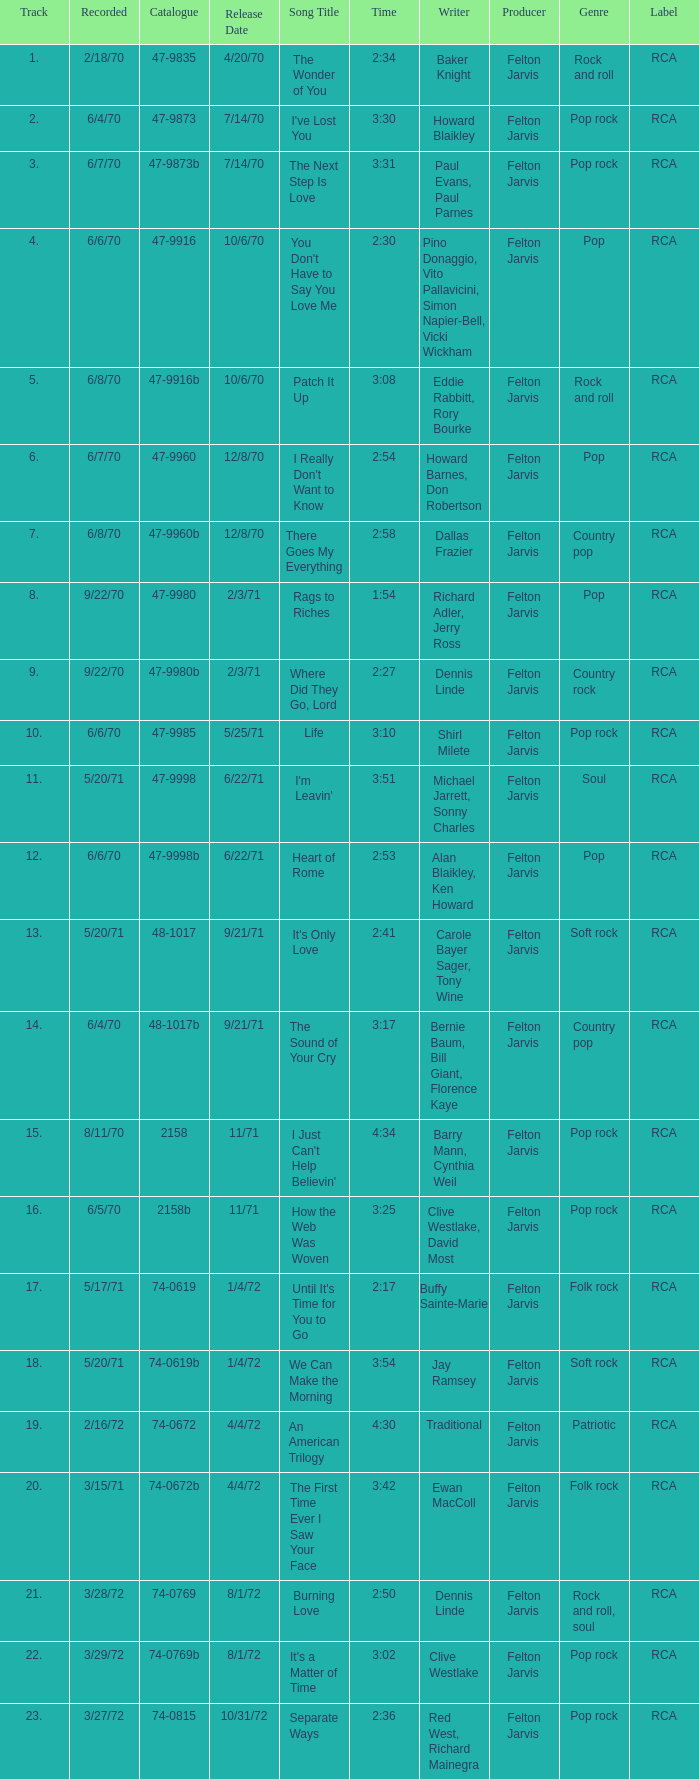What is the highest track for Burning Love? 21.0. 